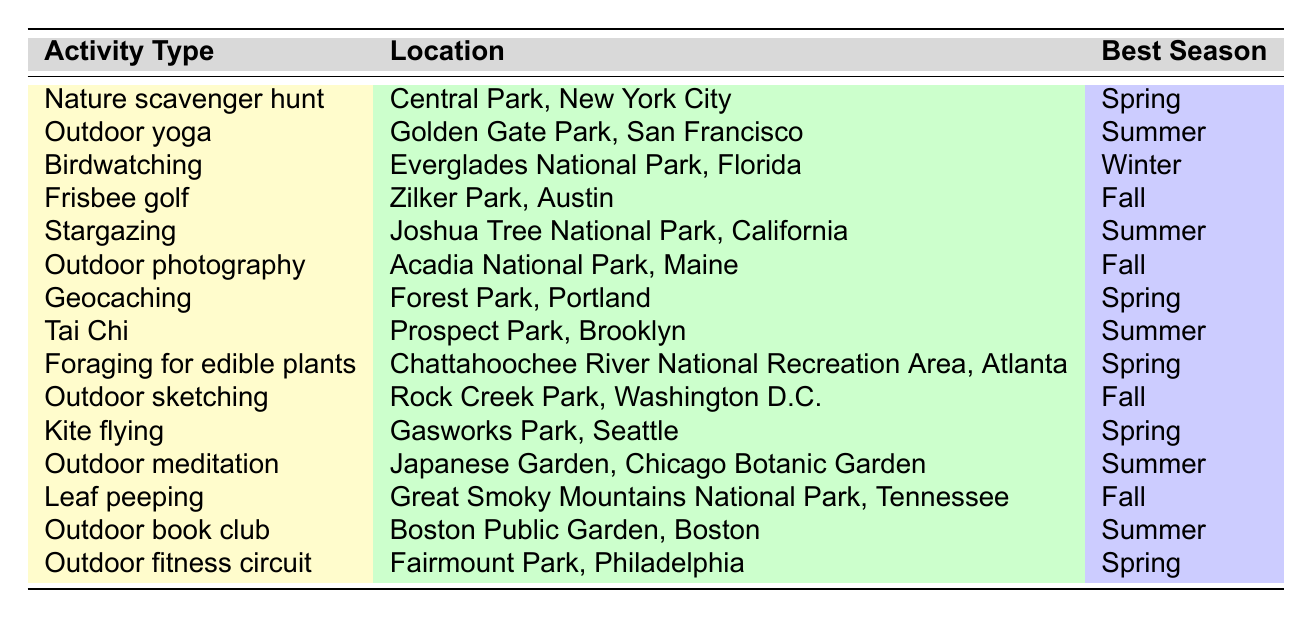What activity has the best season of Spring? By looking at the "Best Season" column, we see that Nature scavenger hunt, Geocaching, Foraging for edible plants, and Kite flying all have Spring as their best season.
Answer: Nature scavenger hunt, Geocaching, Foraging for edible plants, Kite flying Which location is associated with Outdoor yoga? The table lists Golden Gate Park, San Francisco as the location corresponding to Outdoor yoga in the "Location" column.
Answer: Golden Gate Park, San Francisco How many activities are best in Summer? In the "Best Season" column, we count the activities listed as Summer: Outdoor yoga, Stargazing, Tai Chi, Outdoor meditation, and Outdoor book club. That totals to 5 activities.
Answer: 5 Is birdwatching the only activity listed for Winter? Reviewing the "Best Season" column, birdwatching is the only activity listed for Winter, confirming that it is unique in this set.
Answer: Yes Which activity has the same best season as Foraging for edible plants? Foraging for edible plants shares the best season of Spring with Nature scavenger hunt, Geocaching, and Kite flying, as seen in the "Best Season" column.
Answer: Nature scavenger hunt, Geocaching, Kite flying What is the location associated with the activity of Frisbee golf? Frisbee golf is associated with Zilker Park, Austin, as stated in the "Location" column of the table.
Answer: Zilker Park, Austin How many activities can you do in Fall? The "Best Season" column shows that Frisbee golf, Outdoor photography, Outdoor sketching, and Leaf peeping are all best in Fall, leading to a total of 4 activities.
Answer: 4 Is Tai Chi best performed in Spring? Checking the "Best Season" column, Tai Chi is listed with Summer as its best season, not Spring.
Answer: No Which activities are listed for the location of Great Smoky Mountains National Park? Only Leaf peeping is mentioned in the table for Great Smoky Mountains National Park, so that is the sole activity associated.
Answer: Leaf peeping What are the seasonal peaks for outdoor activities in Central Park, New York City? The table shows that the only activity for Central Park is Nature scavenger hunt, which peaks in Spring, indicating this is the seasonal peak for activities there.
Answer: Spring 